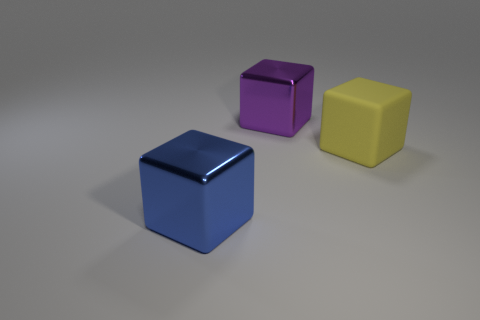How many metal blocks are the same size as the blue shiny thing?
Make the answer very short. 1. How big is the yellow object?
Offer a very short reply. Large. How many big yellow objects are to the left of the big matte block?
Provide a short and direct response. 0. What shape is the big thing that is the same material as the blue block?
Your response must be concise. Cube. Are there fewer purple metal objects that are behind the blue shiny block than big purple shiny things that are left of the purple block?
Your answer should be very brief. No. Is the number of purple metal blocks greater than the number of tiny green blocks?
Keep it short and to the point. Yes. What is the material of the purple thing?
Provide a succinct answer. Metal. The thing that is left of the purple shiny block is what color?
Provide a succinct answer. Blue. Are there more large blue blocks behind the yellow cube than large blue things that are to the right of the large purple cube?
Your answer should be very brief. No. How big is the metal cube on the right side of the large shiny block that is on the left side of the big purple thing on the left side of the yellow block?
Provide a short and direct response. Large. 